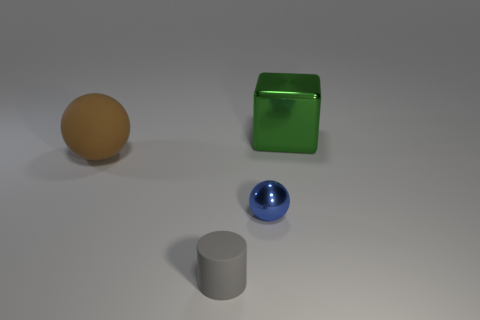How many other things are there of the same material as the green cube?
Provide a succinct answer. 1. There is a shiny object that is left of the metallic object that is to the right of the shiny thing that is in front of the large brown thing; what shape is it?
Give a very brief answer. Sphere. Is the number of small blue things to the left of the brown ball less than the number of big balls that are in front of the tiny blue shiny object?
Make the answer very short. No. Are there any other tiny things of the same color as the tiny matte thing?
Provide a short and direct response. No. Does the brown sphere have the same material as the object in front of the tiny metal thing?
Your answer should be compact. Yes. Is there a thing on the left side of the large thing on the right side of the large brown matte sphere?
Give a very brief answer. Yes. There is a object that is both behind the blue thing and left of the large green thing; what is its color?
Offer a very short reply. Brown. How big is the gray matte cylinder?
Provide a succinct answer. Small. What number of rubber objects have the same size as the green metal block?
Your answer should be compact. 1. Are the large thing that is left of the green shiny cube and the green cube that is behind the blue thing made of the same material?
Give a very brief answer. No. 